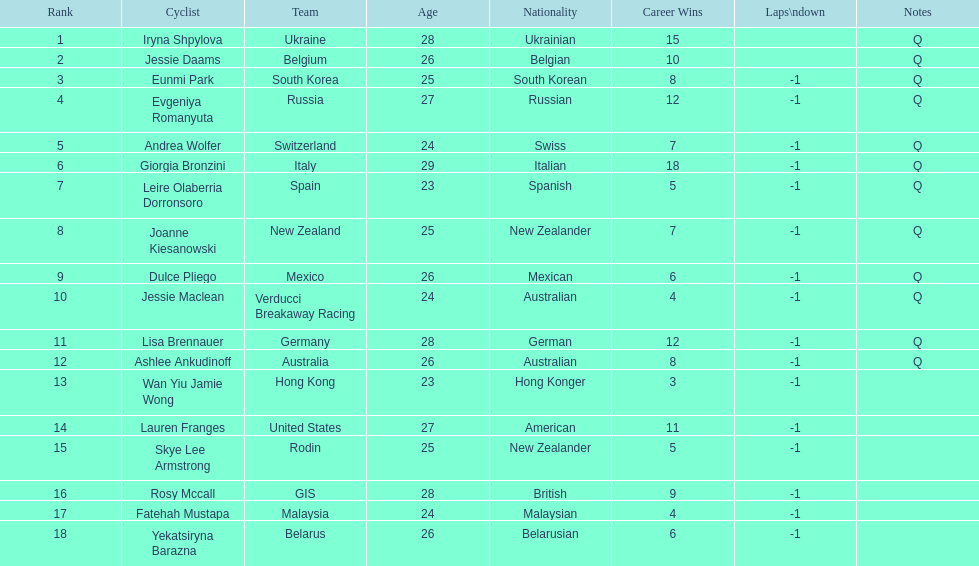What team is listed previous to belgium? Ukraine. 